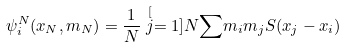Convert formula to latex. <formula><loc_0><loc_0><loc_500><loc_500>\psi _ { i } ^ { N } ( x _ { N } , m _ { N } ) = \frac { 1 } { N } \stackrel { [ } { j } = 1 ] { N } { \sum } m _ { i } m _ { j } S ( x _ { j } - x _ { i } )</formula> 